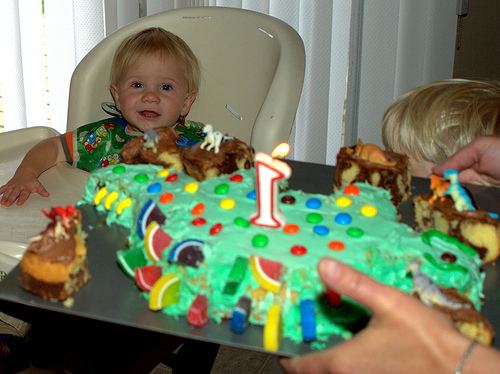<image>
Can you confirm if the number is to the right of the happy child? Yes. From this viewpoint, the number is positioned to the right side relative to the happy child. 